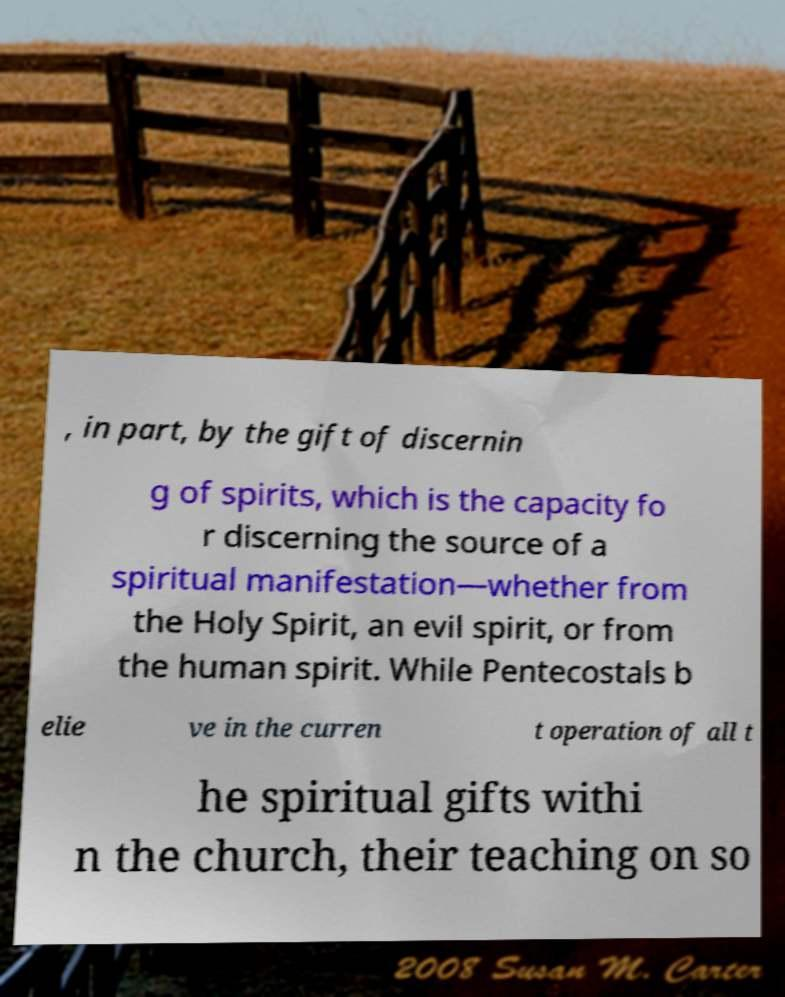Could you extract and type out the text from this image? , in part, by the gift of discernin g of spirits, which is the capacity fo r discerning the source of a spiritual manifestation—whether from the Holy Spirit, an evil spirit, or from the human spirit. While Pentecostals b elie ve in the curren t operation of all t he spiritual gifts withi n the church, their teaching on so 